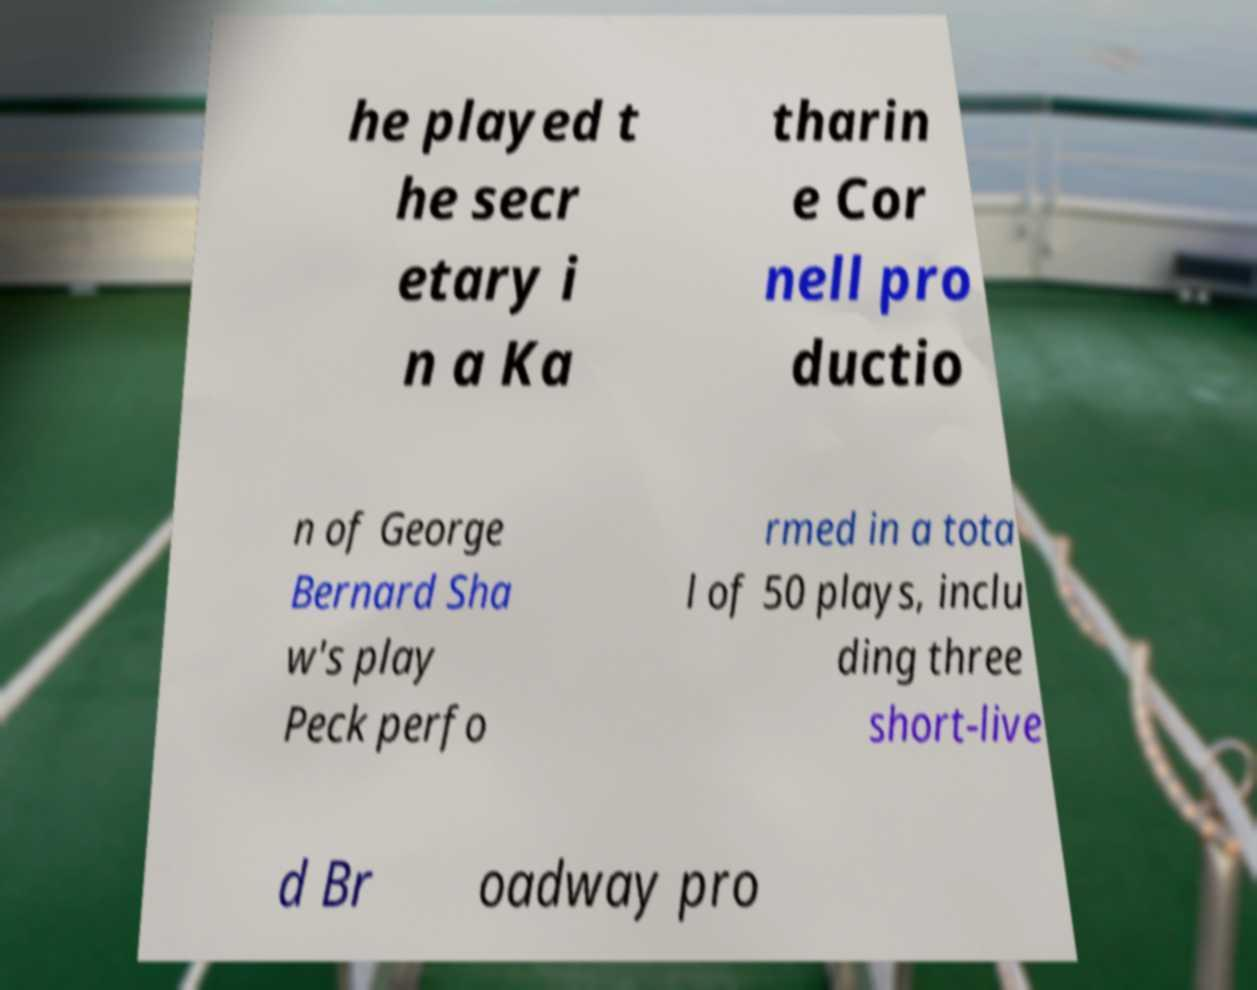Please read and relay the text visible in this image. What does it say? he played t he secr etary i n a Ka tharin e Cor nell pro ductio n of George Bernard Sha w's play Peck perfo rmed in a tota l of 50 plays, inclu ding three short-live d Br oadway pro 